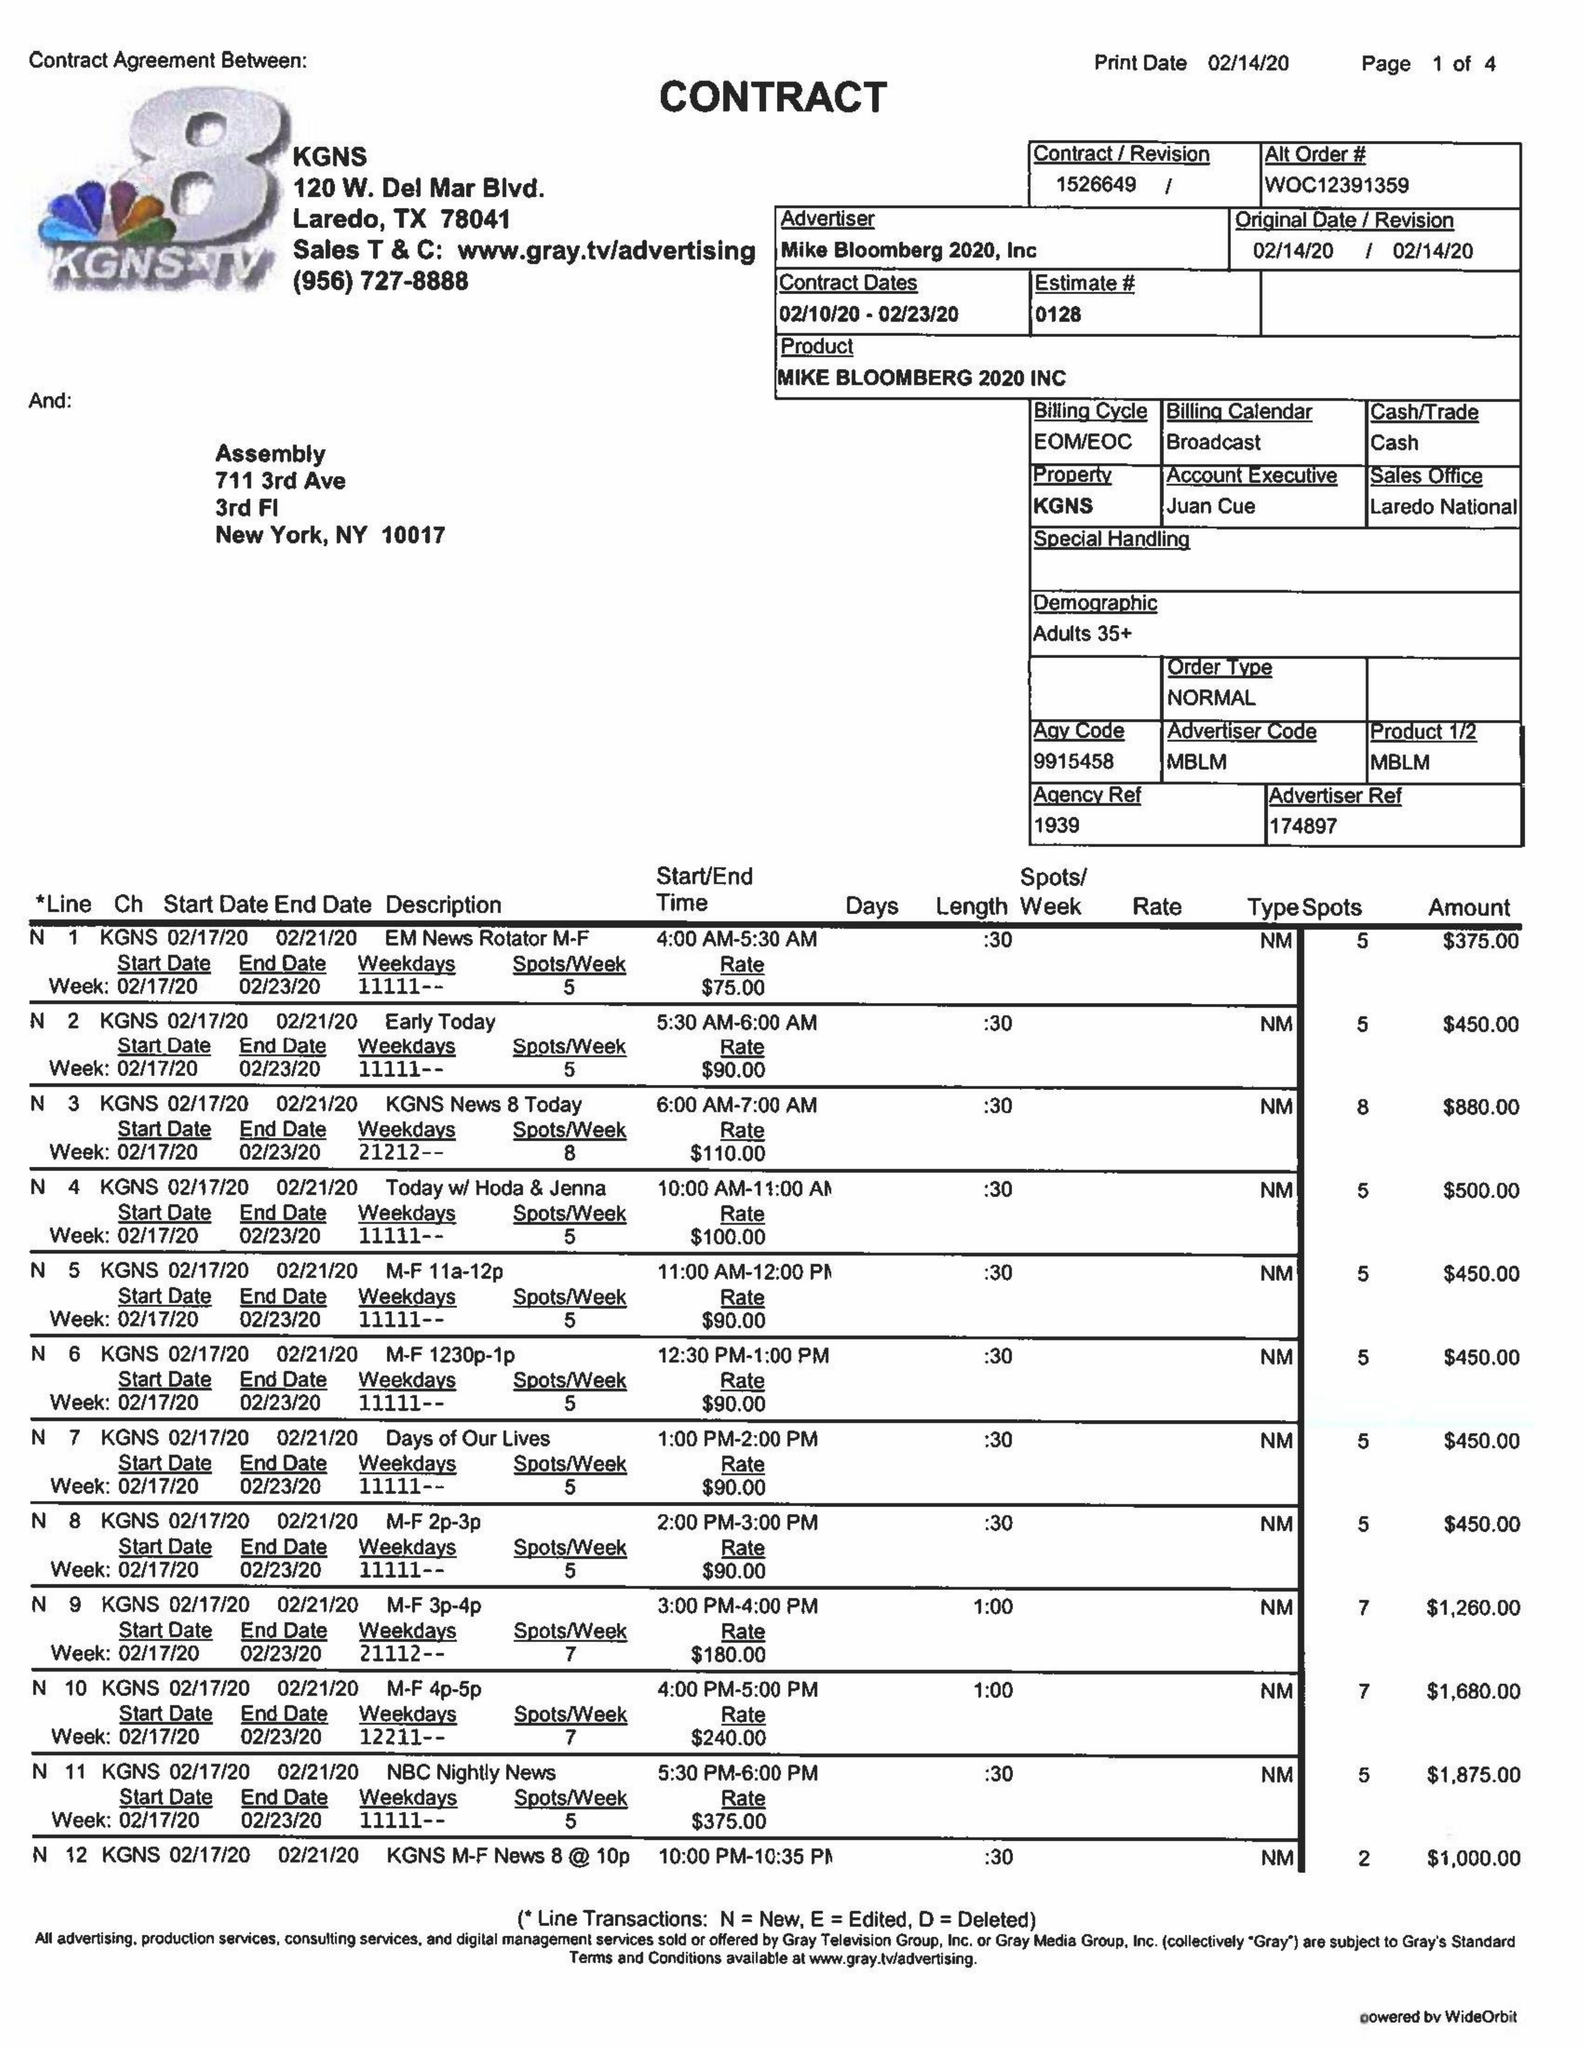What is the value for the flight_from?
Answer the question using a single word or phrase. 02/10/20 